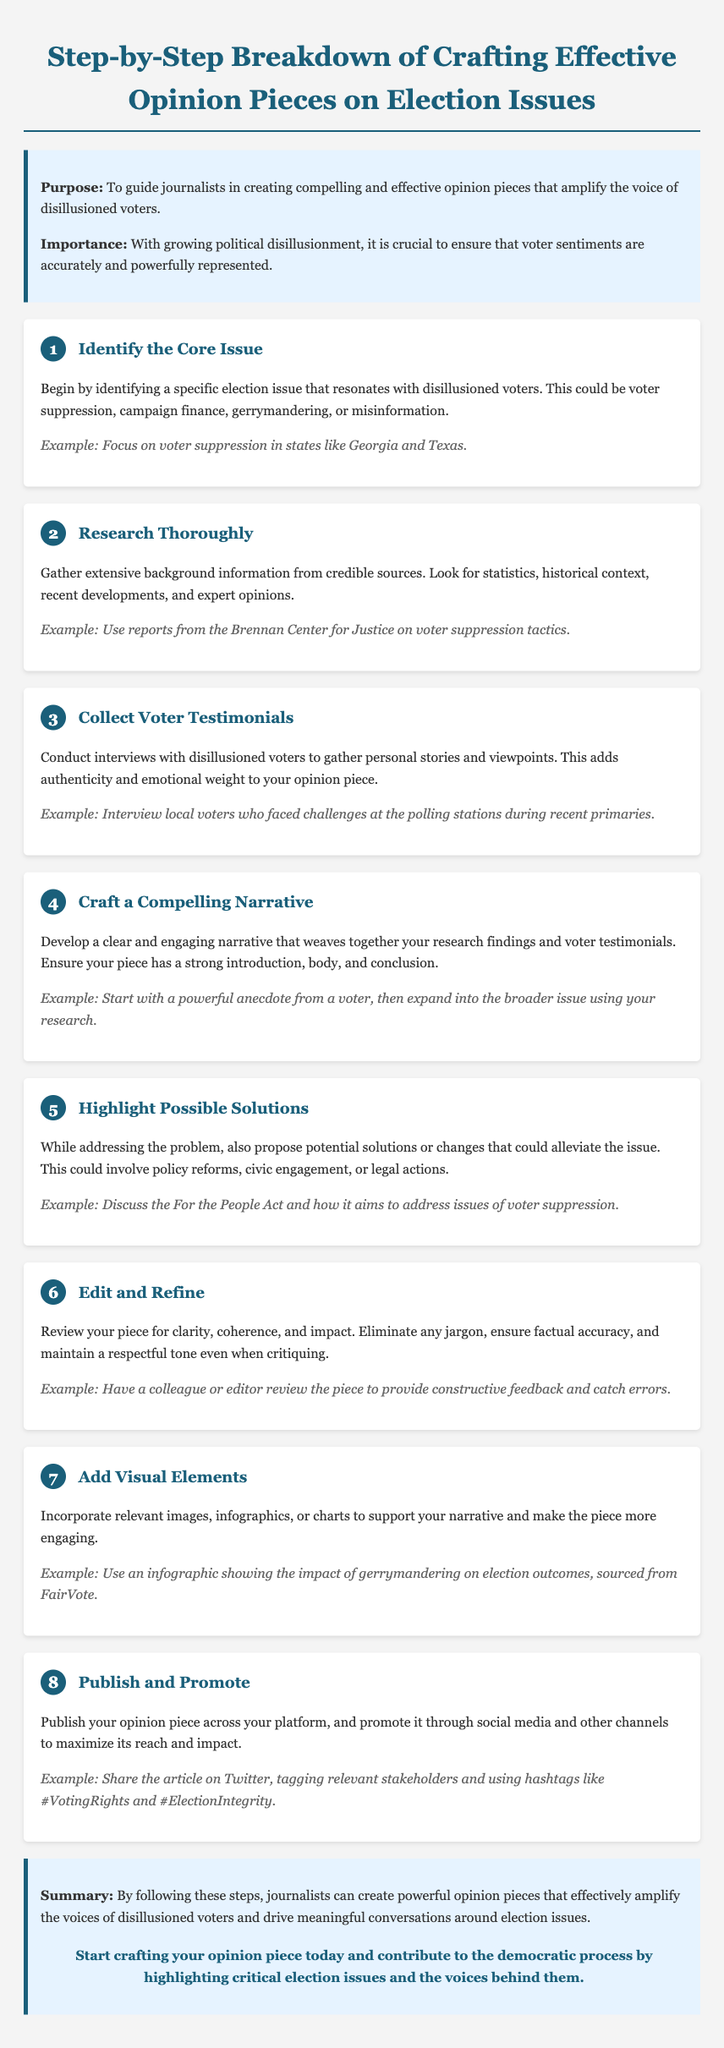What is the title of the document? The title is prominently displayed at the top of the document, indicating the focus on opinion pieces.
Answer: Step-by-Step Breakdown of Crafting Effective Opinion Pieces on Election Issues What is the example issue to focus on in Step 1? The example provided in Step 1 illustrates a specific context relevant to disillusioned voters.
Answer: Voter suppression in states like Georgia and Texas How many steps are outlined in the document? The steps are sequentially numbered, providing a clear count of the process described.
Answer: 8 Which step involves conducting interviews? This step specifically pertains to gathering personal insights from voters to enrich the narrative.
Answer: Step 3 What does Step 5 emphasize? This step focuses on exploring solutions related to the identified issue and discussing potential actions.
Answer: Highlight Possible Solutions What visual elements are suggested to be added? The document outlines the incorporation of certain types of visuals to enhance engagement and support the narrative.
Answer: Images, infographics, or charts What is the call-to-action in the conclusion? The conclusion includes a motivational phrase encouraging proactive contribution to the democratic process.
Answer: Start crafting your opinion piece today Which organization is mentioned as a credible source? The example in Step 2 refers to a reputable organization known for its research on voter issues.
Answer: Brennan Center for Justice 